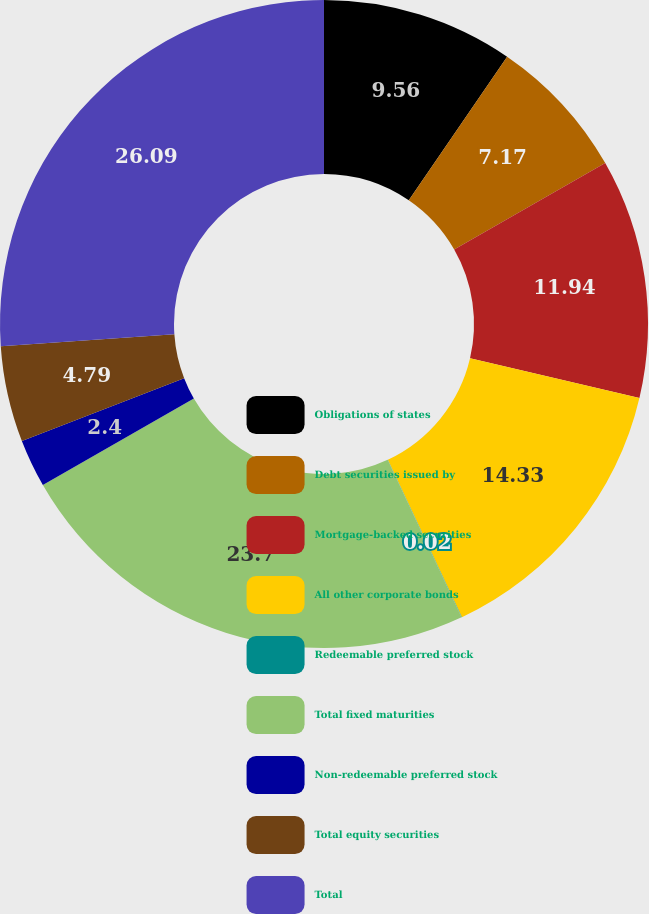Convert chart to OTSL. <chart><loc_0><loc_0><loc_500><loc_500><pie_chart><fcel>Obligations of states<fcel>Debt securities issued by<fcel>Mortgage-backed securities<fcel>All other corporate bonds<fcel>Redeemable preferred stock<fcel>Total fixed maturities<fcel>Non-redeemable preferred stock<fcel>Total equity securities<fcel>Total<nl><fcel>9.56%<fcel>7.17%<fcel>11.94%<fcel>14.33%<fcel>0.02%<fcel>23.7%<fcel>2.4%<fcel>4.79%<fcel>26.09%<nl></chart> 